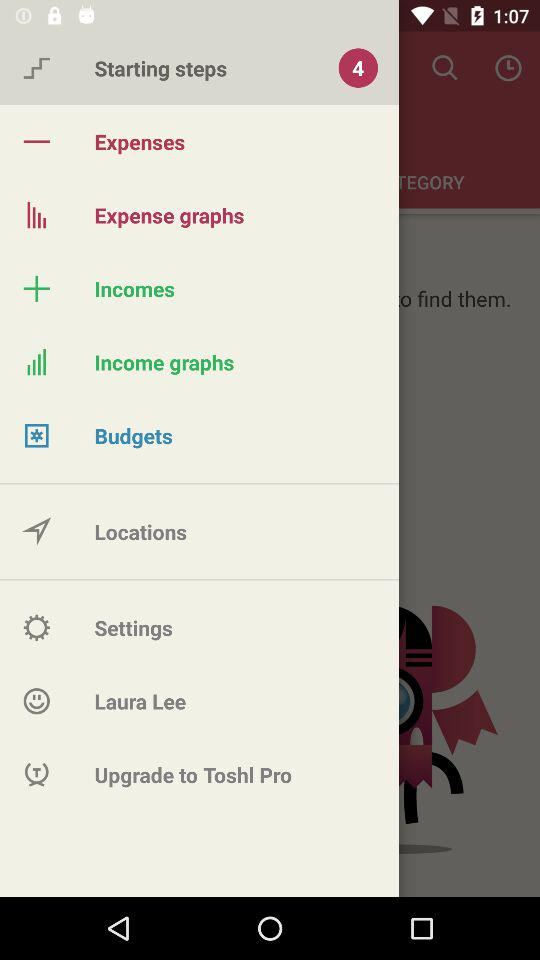How many notifications are there for "Starting steps"? There are 4 notifications for "Starting steps". 